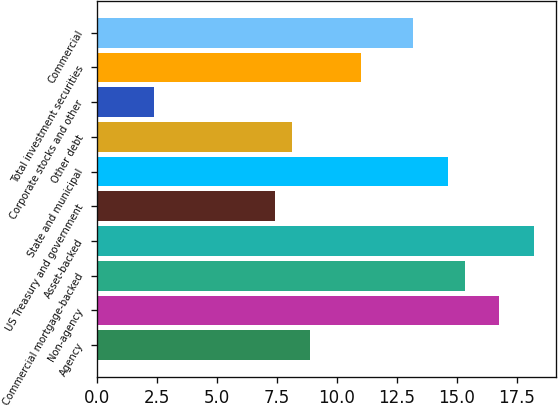<chart> <loc_0><loc_0><loc_500><loc_500><bar_chart><fcel>Agency<fcel>Non-agency<fcel>Commercial mortgage-backed<fcel>Asset-backed<fcel>US Treasury and government<fcel>State and municipal<fcel>Other debt<fcel>Corporate stocks and other<fcel>Total investment securities<fcel>Commercial<nl><fcel>8.86<fcel>16.78<fcel>15.34<fcel>18.22<fcel>7.42<fcel>14.62<fcel>8.14<fcel>2.38<fcel>11.02<fcel>13.18<nl></chart> 